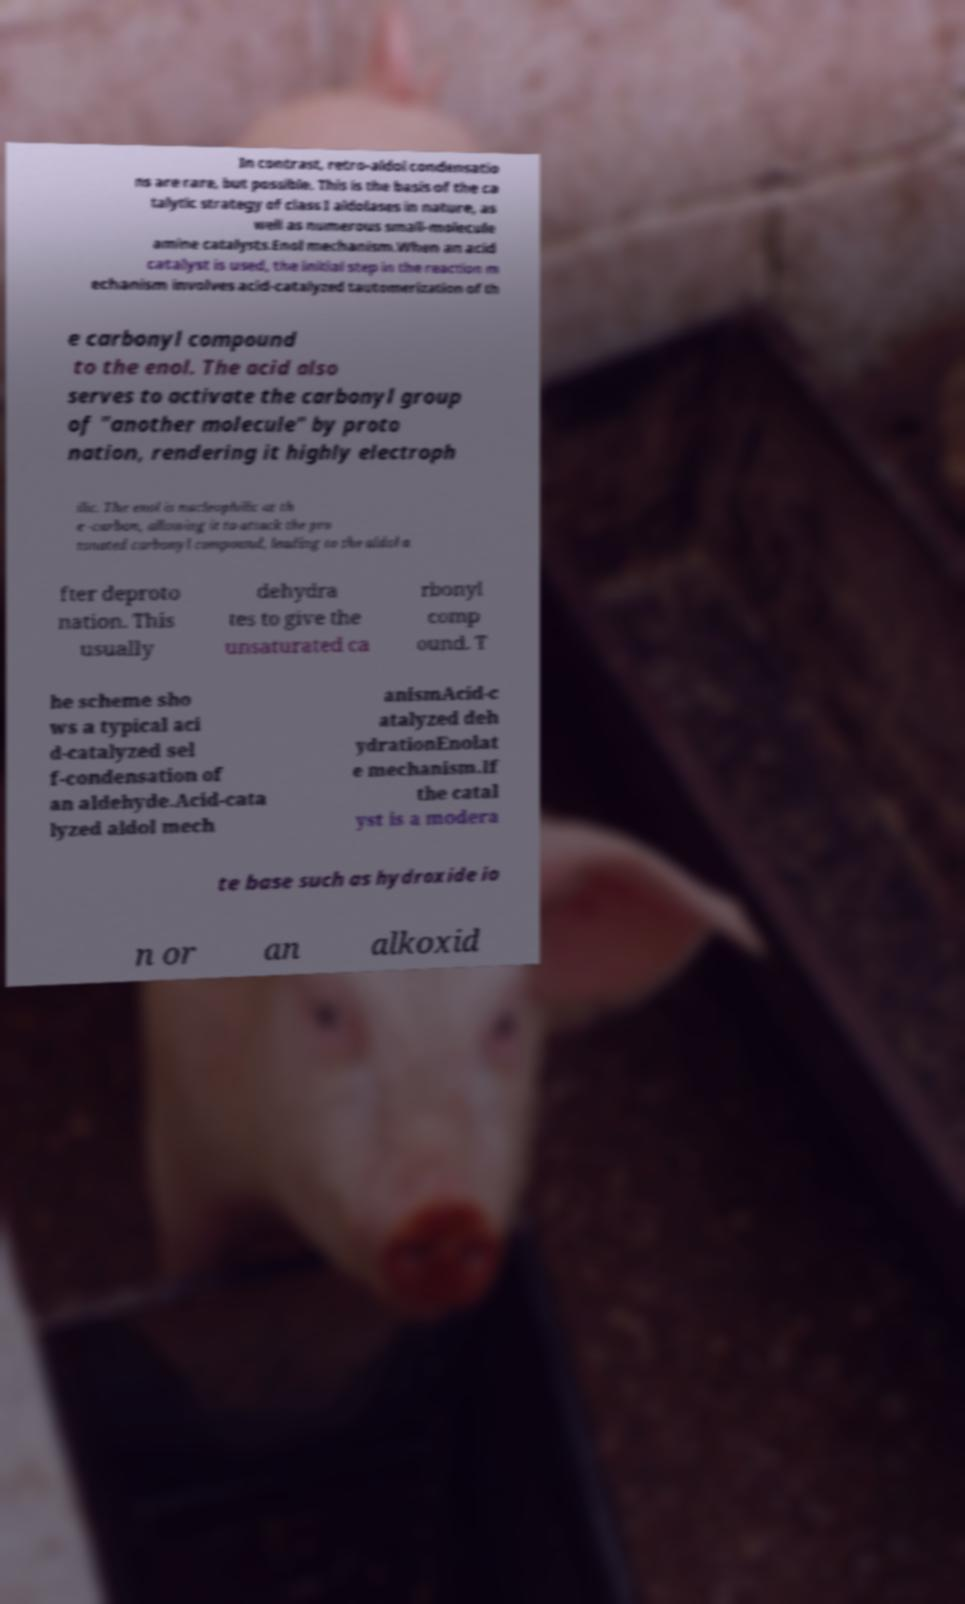Please identify and transcribe the text found in this image. In contrast, retro-aldol condensatio ns are rare, but possible. This is the basis of the ca talytic strategy of class I aldolases in nature, as well as numerous small-molecule amine catalysts.Enol mechanism.When an acid catalyst is used, the initial step in the reaction m echanism involves acid-catalyzed tautomerization of th e carbonyl compound to the enol. The acid also serves to activate the carbonyl group of "another molecule" by proto nation, rendering it highly electroph ilic. The enol is nucleophilic at th e -carbon, allowing it to attack the pro tonated carbonyl compound, leading to the aldol a fter deproto nation. This usually dehydra tes to give the unsaturated ca rbonyl comp ound. T he scheme sho ws a typical aci d-catalyzed sel f-condensation of an aldehyde.Acid-cata lyzed aldol mech anismAcid-c atalyzed deh ydrationEnolat e mechanism.If the catal yst is a modera te base such as hydroxide io n or an alkoxid 